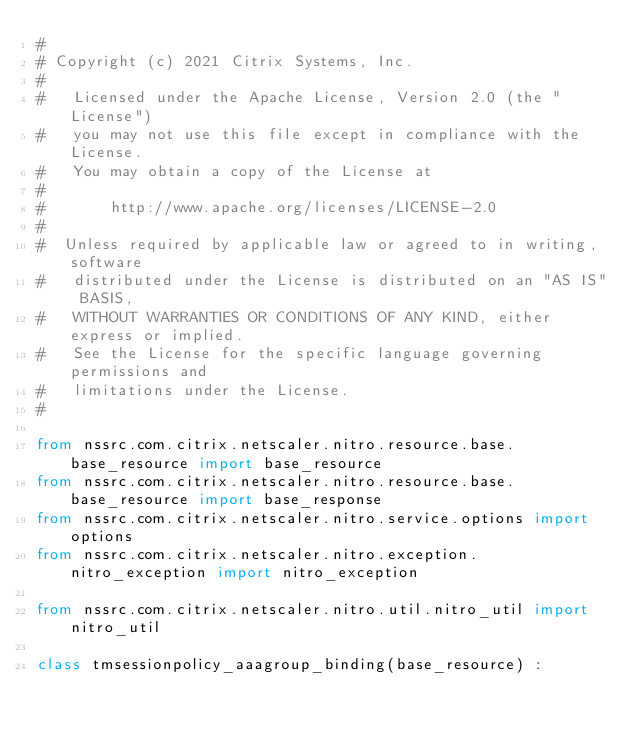Convert code to text. <code><loc_0><loc_0><loc_500><loc_500><_Python_>#
# Copyright (c) 2021 Citrix Systems, Inc.
#
#   Licensed under the Apache License, Version 2.0 (the "License")
#   you may not use this file except in compliance with the License.
#   You may obtain a copy of the License at
#
#       http://www.apache.org/licenses/LICENSE-2.0
#
#  Unless required by applicable law or agreed to in writing, software
#   distributed under the License is distributed on an "AS IS" BASIS,
#   WITHOUT WARRANTIES OR CONDITIONS OF ANY KIND, either express or implied.
#   See the License for the specific language governing permissions and
#   limitations under the License.
#

from nssrc.com.citrix.netscaler.nitro.resource.base.base_resource import base_resource
from nssrc.com.citrix.netscaler.nitro.resource.base.base_resource import base_response
from nssrc.com.citrix.netscaler.nitro.service.options import options
from nssrc.com.citrix.netscaler.nitro.exception.nitro_exception import nitro_exception

from nssrc.com.citrix.netscaler.nitro.util.nitro_util import nitro_util

class tmsessionpolicy_aaagroup_binding(base_resource) :</code> 